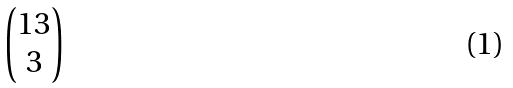Convert formula to latex. <formula><loc_0><loc_0><loc_500><loc_500>\begin{pmatrix} 1 3 \\ 3 \end{pmatrix}</formula> 